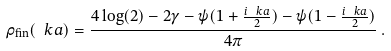Convert formula to latex. <formula><loc_0><loc_0><loc_500><loc_500>\rho _ { \text {fin} } ( \ k a ) = \frac { 4 \log ( 2 ) - 2 \gamma - \psi ( 1 + \frac { i \ k a } { 2 } ) - \psi ( 1 - \frac { i \ k a } { 2 } ) } { 4 \pi } \, .</formula> 